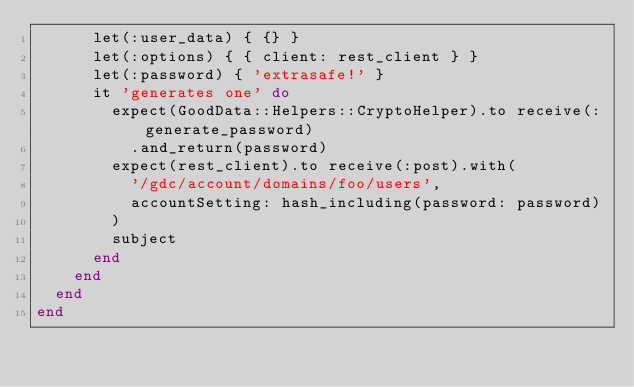<code> <loc_0><loc_0><loc_500><loc_500><_Ruby_>      let(:user_data) { {} }
      let(:options) { { client: rest_client } }
      let(:password) { 'extrasafe!' }
      it 'generates one' do
        expect(GoodData::Helpers::CryptoHelper).to receive(:generate_password)
          .and_return(password)
        expect(rest_client).to receive(:post).with(
          '/gdc/account/domains/foo/users',
          accountSetting: hash_including(password: password)
        )
        subject
      end
    end
  end
end
</code> 